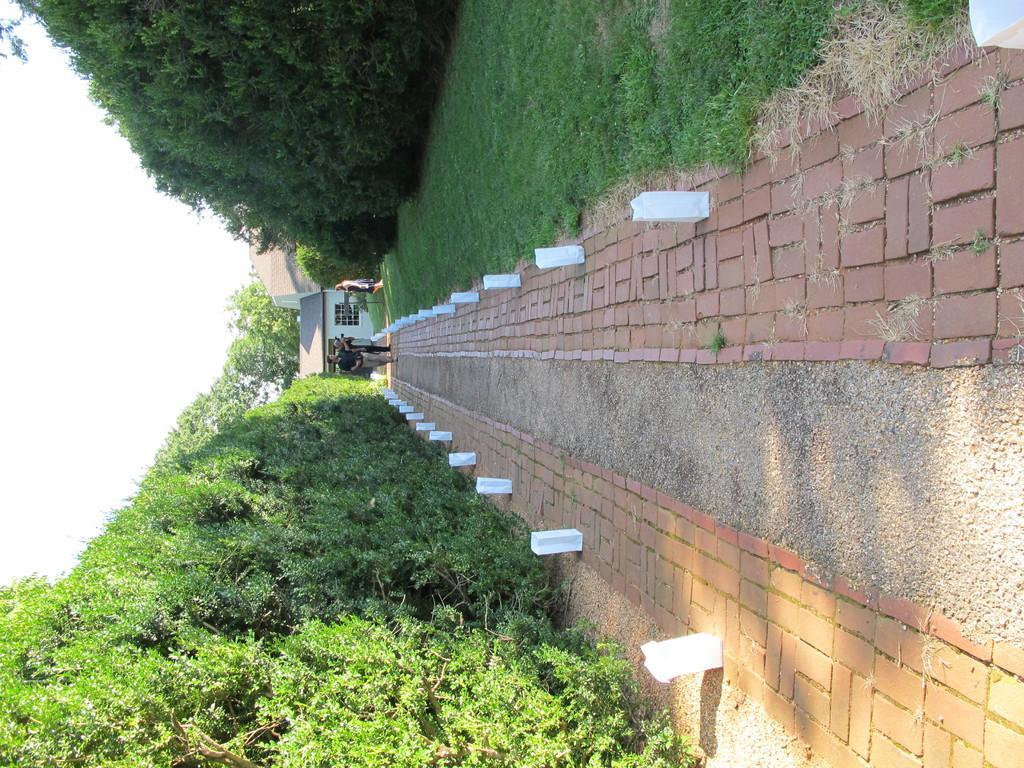In one or two sentences, can you explain what this image depicts? This is a tilted image, in this image, at the top there are trees, at the bottom there are trees, in the middle there is a path, on that path people are walking, in the background there are houses and the sky. 